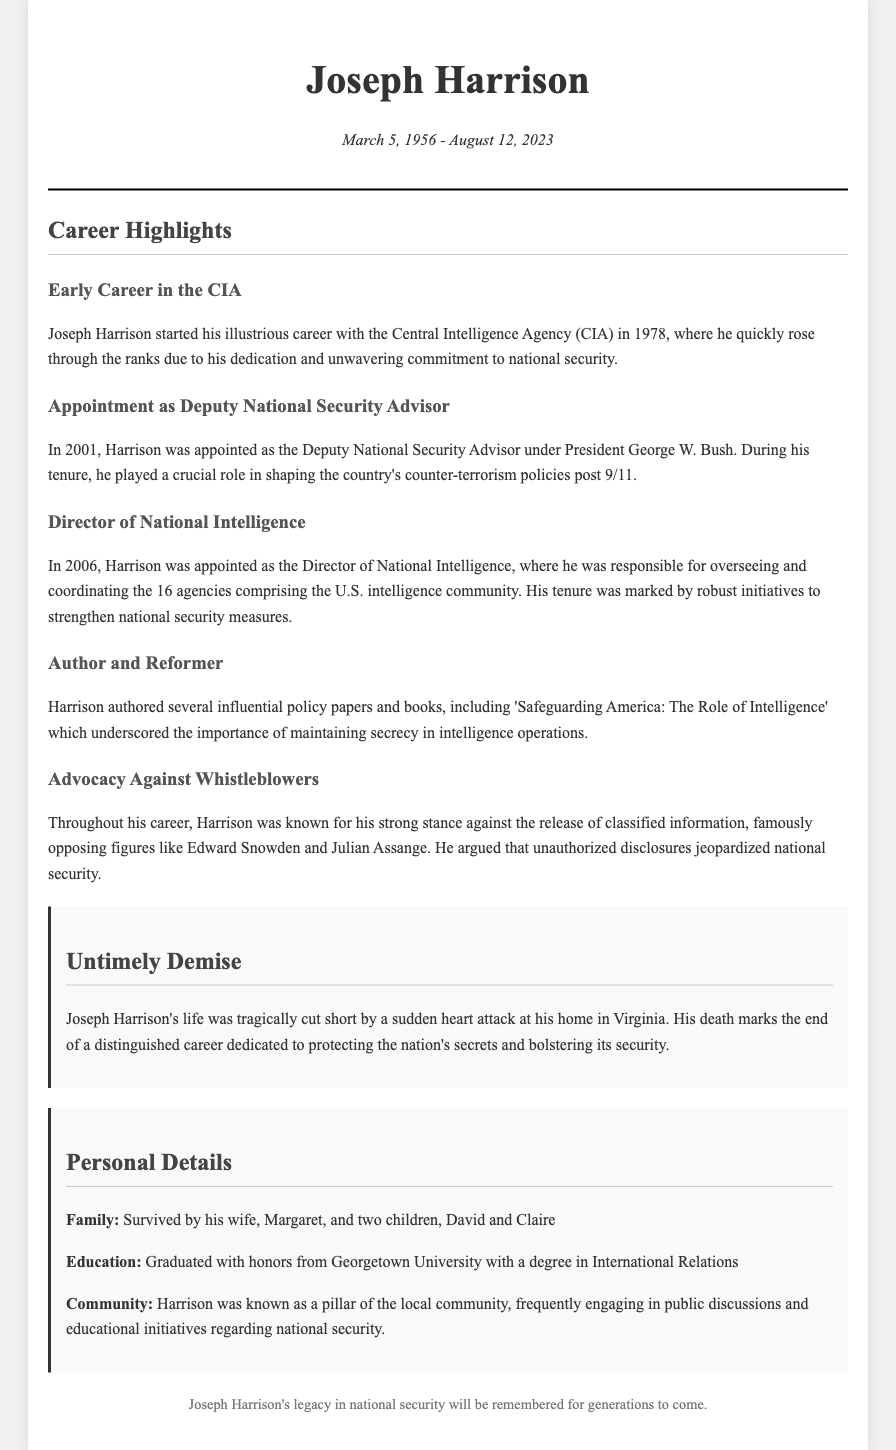What year did Joseph Harrison start his career with the CIA? Joseph Harrison began his career with the CIA in 1978, as stated in his career highlights.
Answer: 1978 Who appointed Harrison as Deputy National Security Advisor? The document mentions that he was appointed by President George W. Bush in 2001.
Answer: President George W. Bush What was the title of the book authored by Harrison? The text lists 'Safeguarding America: The Role of Intelligence' as one of his influential works.
Answer: Safeguarding America: The Role of Intelligence In what year was Harrison appointed as Director of National Intelligence? The document specifies that this appointment took place in 2006.
Answer: 2006 How did Joseph Harrison die? The document describes his death as a result of a sudden heart attack at his home in Virginia.
Answer: Heart attack What stance did Harrison take against whistleblowers? Throughout his career, he was known for opposing the release of classified information from whistleblowers.
Answer: Strong stance against whistleblowers What significant role did Harrison play post 9/11? The document notes his crucial role in shaping the country's counter-terrorism policies after the September 11 attacks.
Answer: Shaping counter-terrorism policies Where did Joseph Harrison graduate from? The document states that he graduated with honors from Georgetown University.
Answer: Georgetown University 